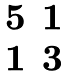<formula> <loc_0><loc_0><loc_500><loc_500>\begin{matrix} 5 & 1 \\ 1 & 3 \end{matrix}</formula> 